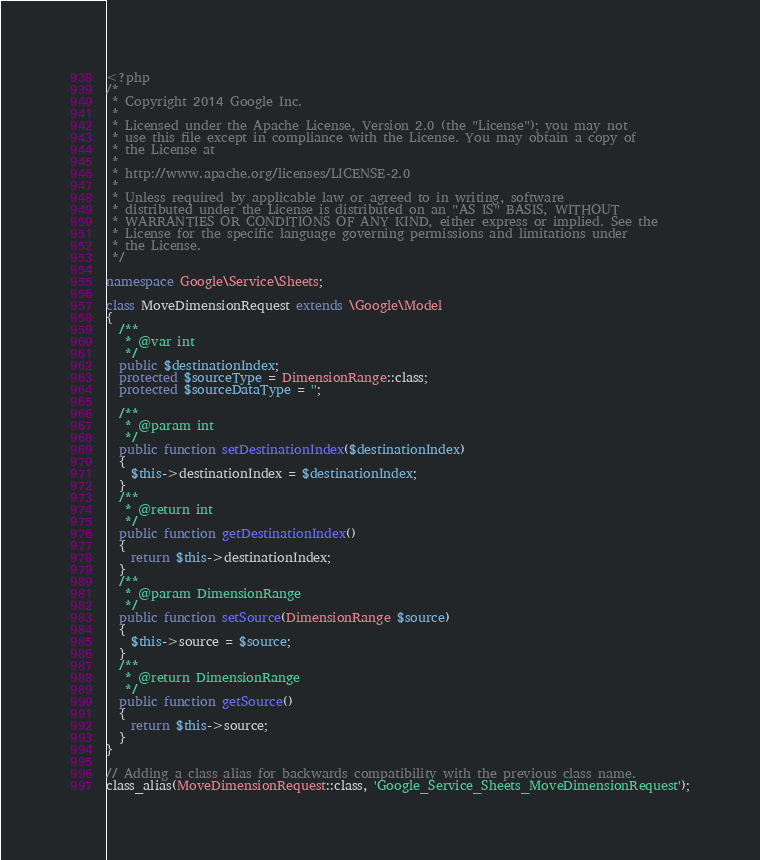<code> <loc_0><loc_0><loc_500><loc_500><_PHP_><?php
/*
 * Copyright 2014 Google Inc.
 *
 * Licensed under the Apache License, Version 2.0 (the "License"); you may not
 * use this file except in compliance with the License. You may obtain a copy of
 * the License at
 *
 * http://www.apache.org/licenses/LICENSE-2.0
 *
 * Unless required by applicable law or agreed to in writing, software
 * distributed under the License is distributed on an "AS IS" BASIS, WITHOUT
 * WARRANTIES OR CONDITIONS OF ANY KIND, either express or implied. See the
 * License for the specific language governing permissions and limitations under
 * the License.
 */

namespace Google\Service\Sheets;

class MoveDimensionRequest extends \Google\Model
{
  /**
   * @var int
   */
  public $destinationIndex;
  protected $sourceType = DimensionRange::class;
  protected $sourceDataType = '';

  /**
   * @param int
   */
  public function setDestinationIndex($destinationIndex)
  {
    $this->destinationIndex = $destinationIndex;
  }
  /**
   * @return int
   */
  public function getDestinationIndex()
  {
    return $this->destinationIndex;
  }
  /**
   * @param DimensionRange
   */
  public function setSource(DimensionRange $source)
  {
    $this->source = $source;
  }
  /**
   * @return DimensionRange
   */
  public function getSource()
  {
    return $this->source;
  }
}

// Adding a class alias for backwards compatibility with the previous class name.
class_alias(MoveDimensionRequest::class, 'Google_Service_Sheets_MoveDimensionRequest');
</code> 